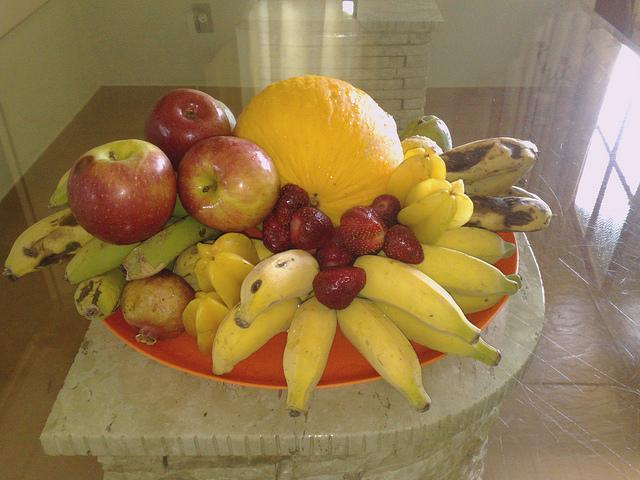What color is the largest fruit on the plate?
From the following set of four choices, select the accurate answer to respond to the question.
Options: Brown, green, yellow, red. Yellow. 